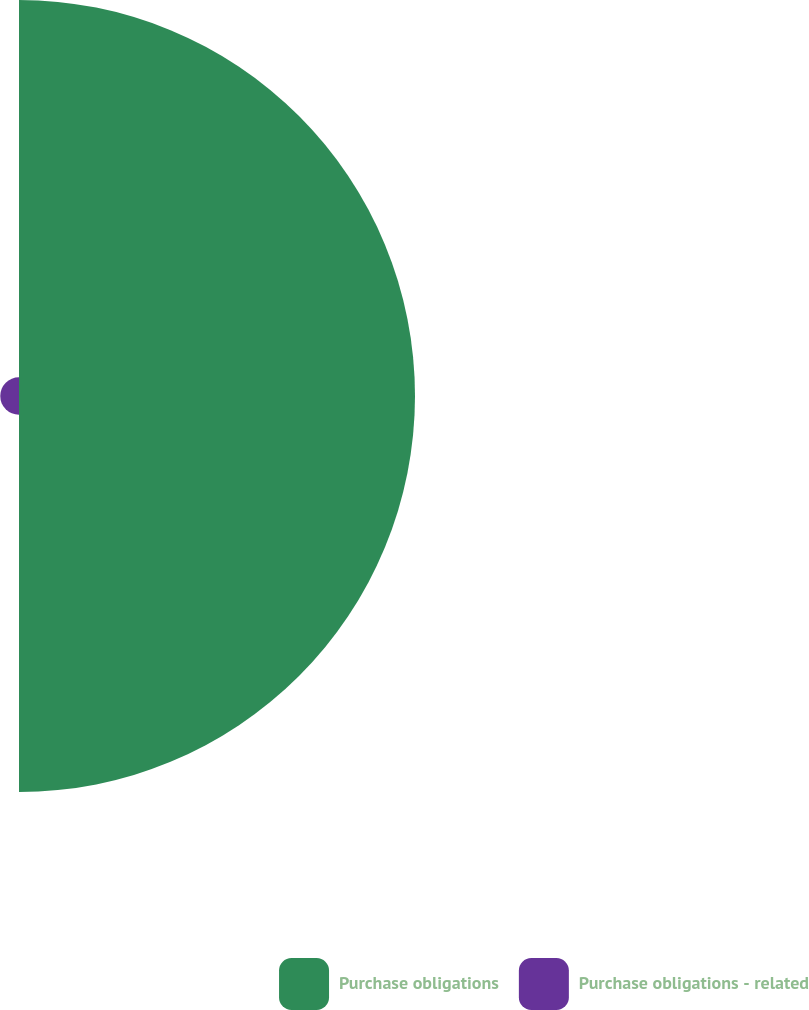Convert chart to OTSL. <chart><loc_0><loc_0><loc_500><loc_500><pie_chart><fcel>Purchase obligations<fcel>Purchase obligations - related<nl><fcel>95.48%<fcel>4.52%<nl></chart> 